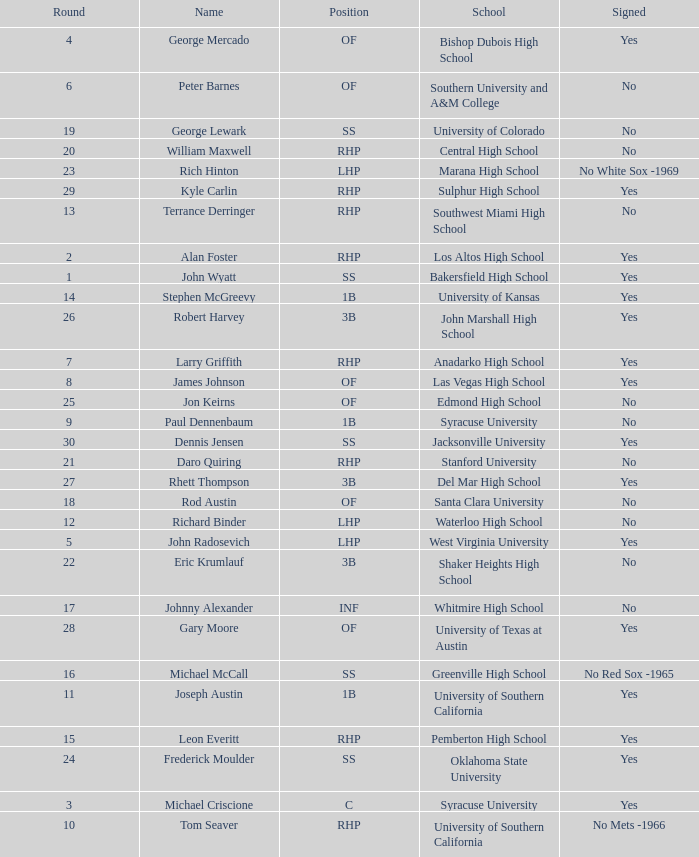What is the name of the player taken in round 23? Rich Hinton. 